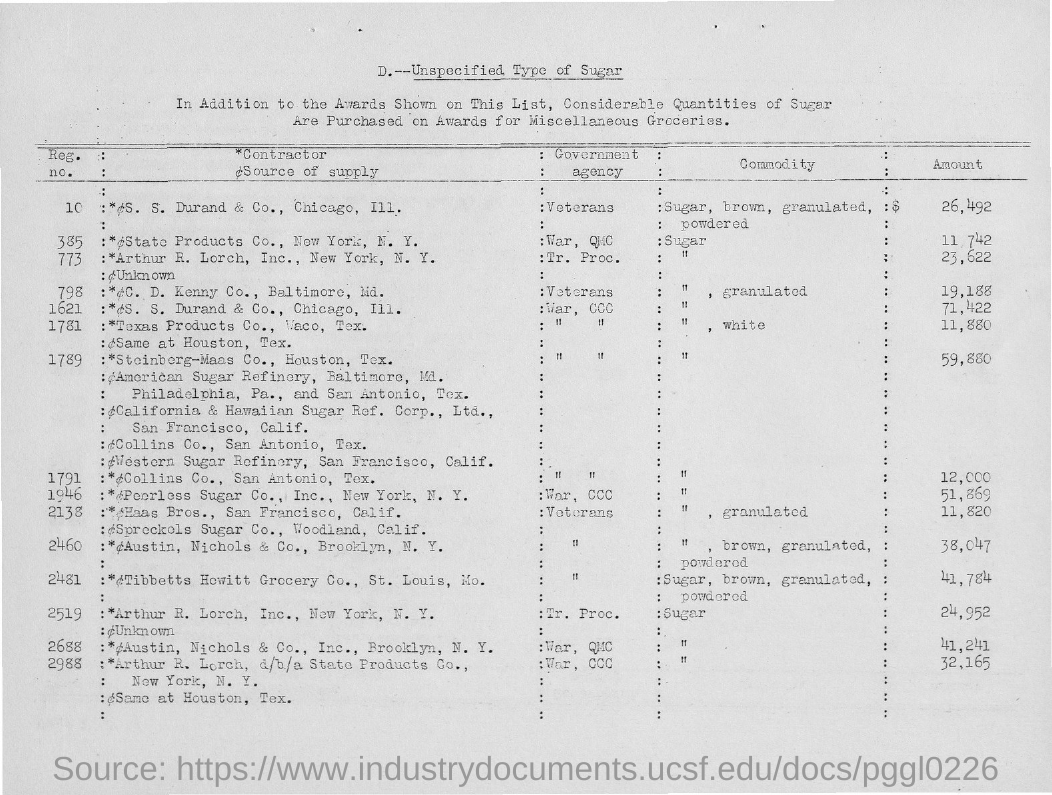Point out several critical features in this image. The amount for registration number 10 is 26,492. 